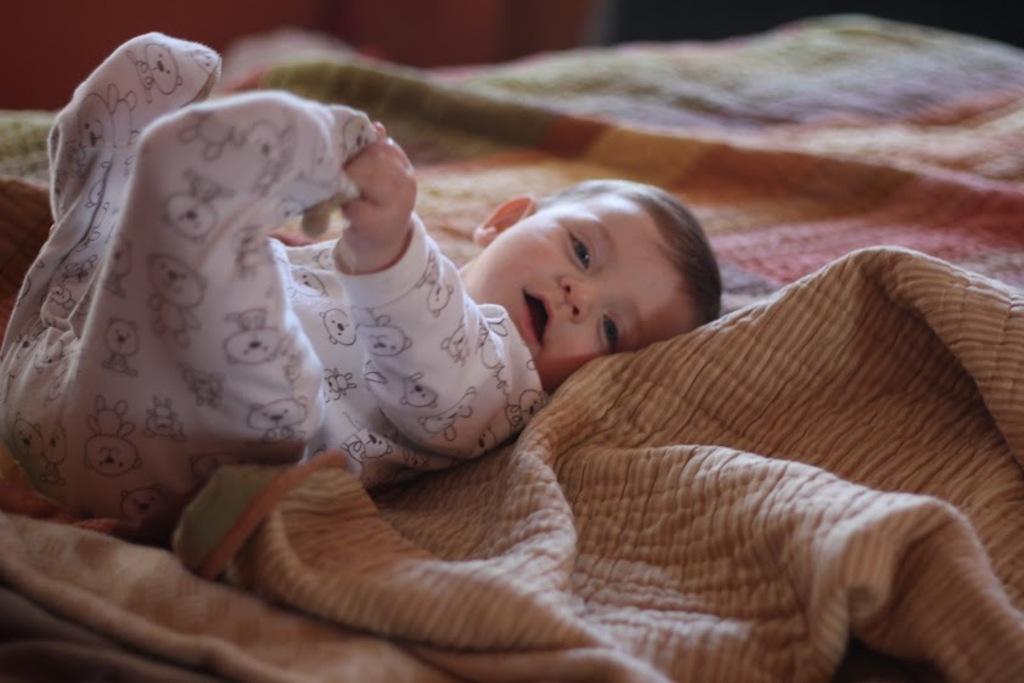Could you give a brief overview of what you see in this image? In the picture I can see a baby wearing white dress is lying on the bed. 